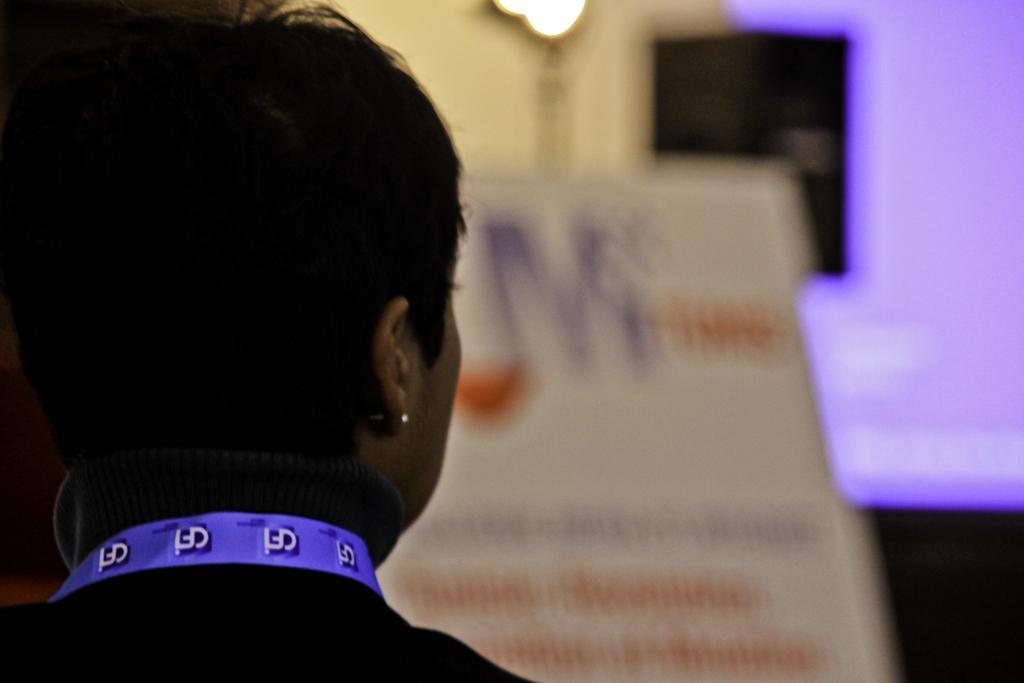Can you describe this image briefly? In this picture there is a lady on the left side of the image and there is a poster in the center of the image, there is lamp at the top side of the image. 